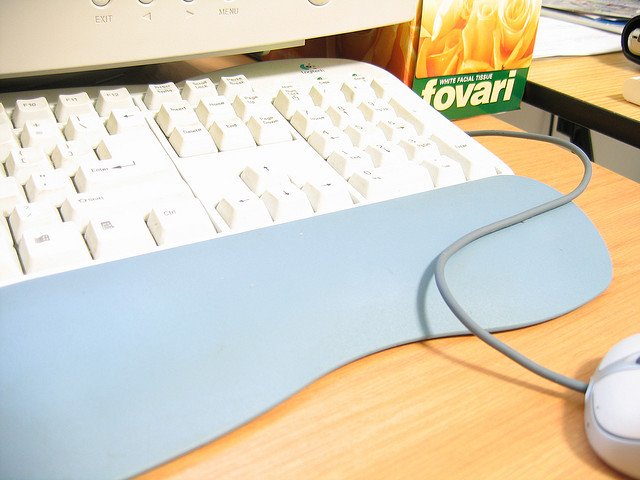Read and extract the text from this image. fovari EXO 